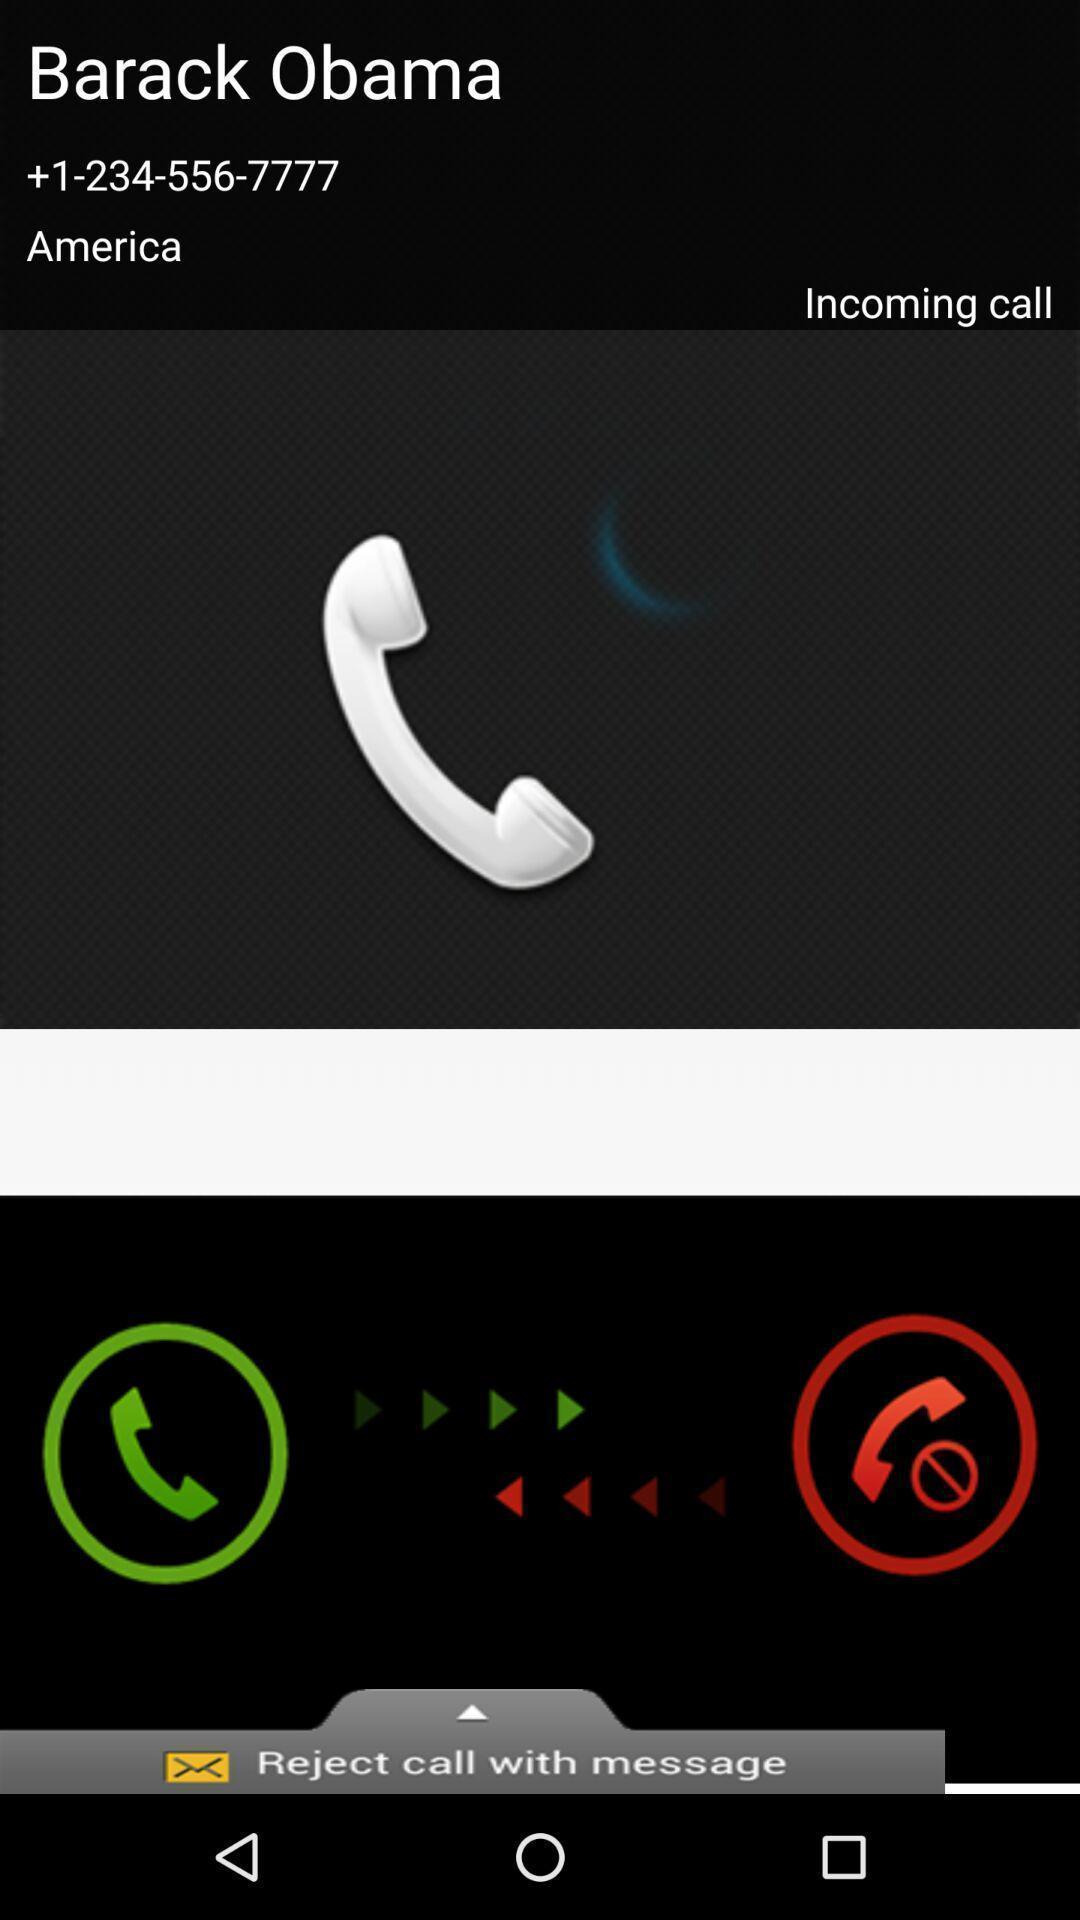Summarize the information in this screenshot. Screen displaying the incoming call. 